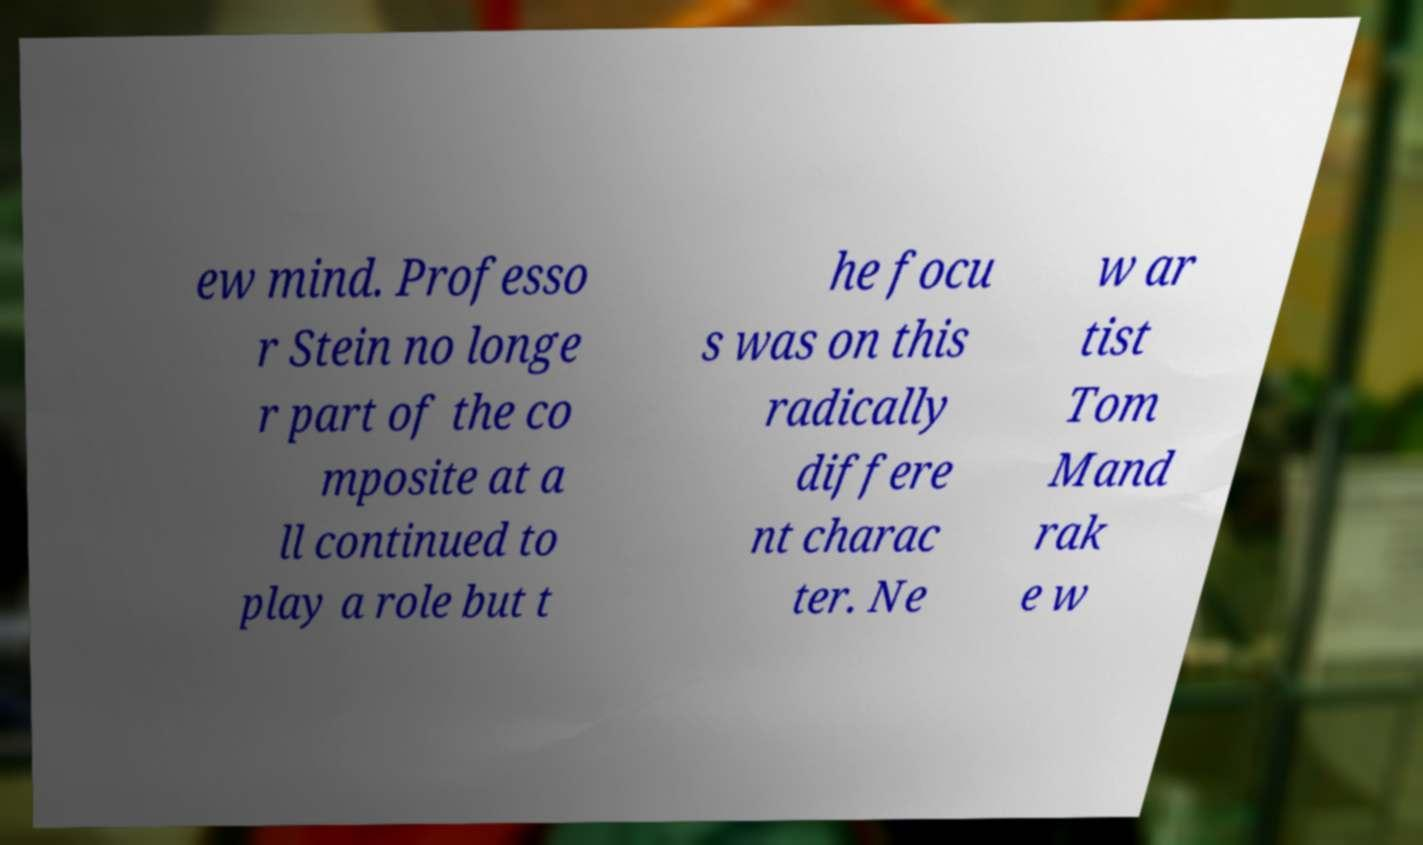Please read and relay the text visible in this image. What does it say? ew mind. Professo r Stein no longe r part of the co mposite at a ll continued to play a role but t he focu s was on this radically differe nt charac ter. Ne w ar tist Tom Mand rak e w 